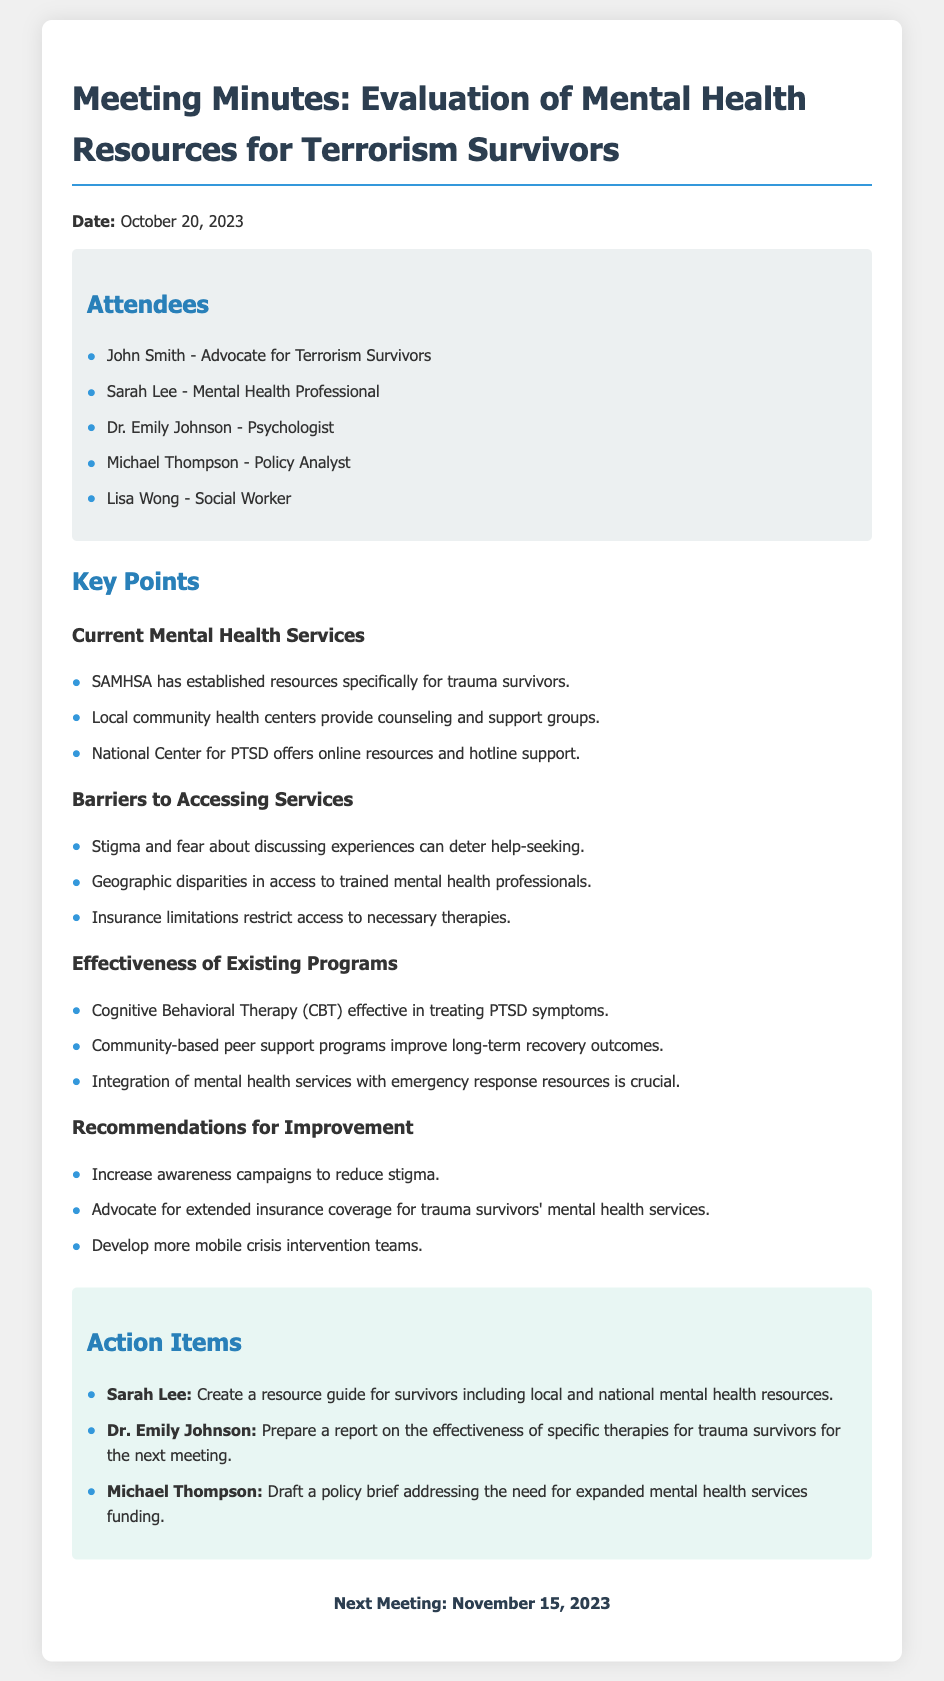What is the date of the meeting? The date of the meeting is provided at the beginning of the document.
Answer: October 20, 2023 Who is the advocate for terrorism survivors attending the meeting? The attendees section lists individuals and their roles.
Answer: John Smith What organization provides online resources and hotline support? The key points mention specific organizations offering services for trauma survivors.
Answer: National Center for PTSD What is one barrier to accessing mental health services mentioned in the document? The barriers section outlines challenges faced by survivors in accessing services.
Answer: Stigma and fear Which therapy is noted as effective in treating PTSD symptoms? The effectiveness section highlights specific therapies and their impacts on trauma survivors.
Answer: Cognitive Behavioral Therapy (CBT) What is an action item assigned to Sarah Lee? The action items outline specific tasks assigned to the attendees during the meeting.
Answer: Create a resource guide for survivors including local and national mental health resources How often do community-based peer support programs improve long-term recovery outcomes? This question requires reasoning about the effectiveness section to extract a specific conclusion.
Answer: Improve long-term recovery outcomes What is the date of the next meeting? The next meeting date is clearly stated at the end of the document.
Answer: November 15, 2023 